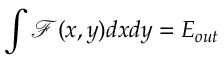Convert formula to latex. <formula><loc_0><loc_0><loc_500><loc_500>\int \mathcal { F } ( x , y ) d x d y = E _ { o u t }</formula> 